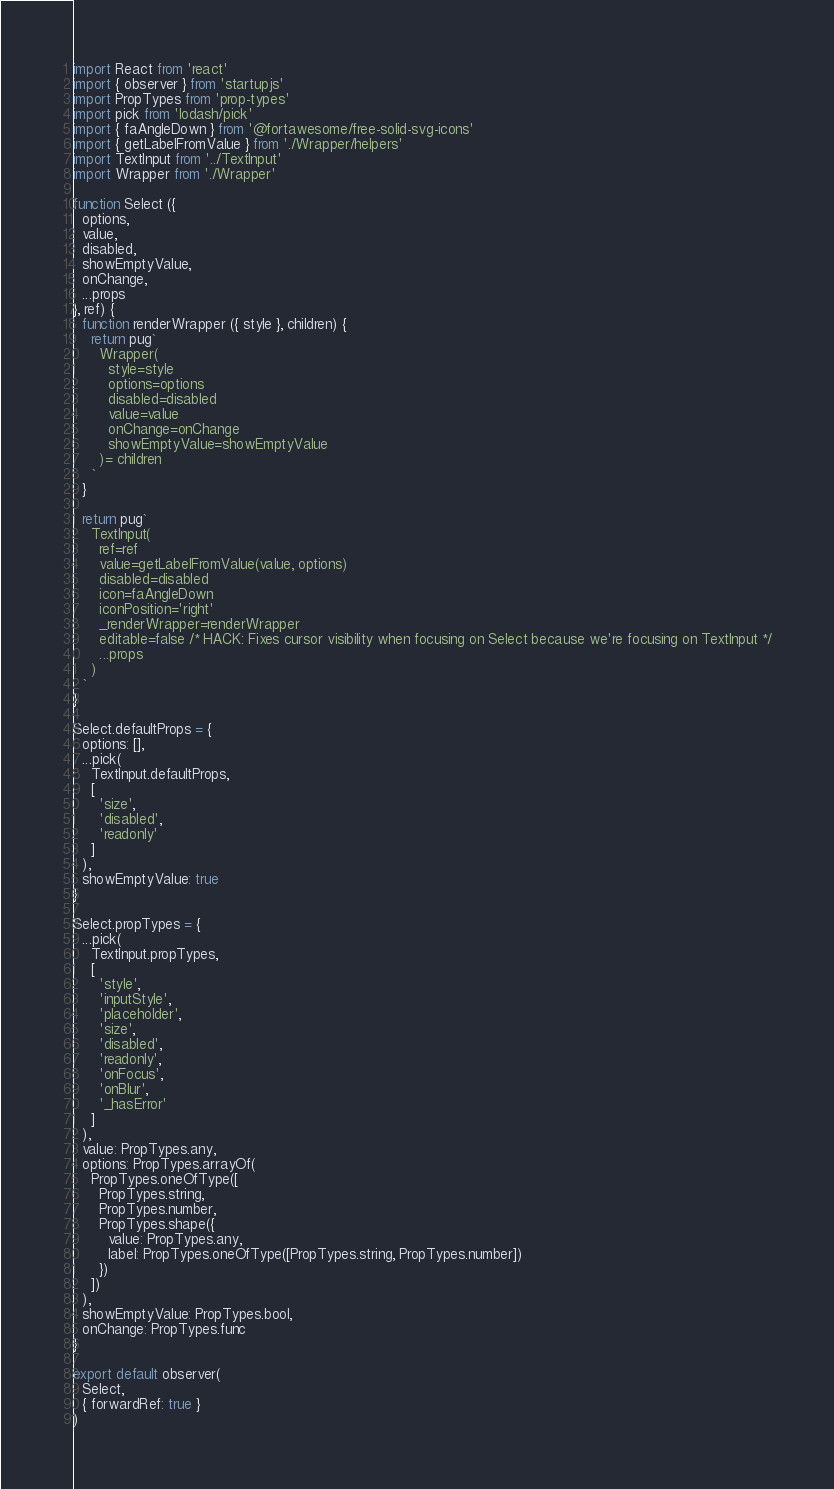<code> <loc_0><loc_0><loc_500><loc_500><_JavaScript_>import React from 'react'
import { observer } from 'startupjs'
import PropTypes from 'prop-types'
import pick from 'lodash/pick'
import { faAngleDown } from '@fortawesome/free-solid-svg-icons'
import { getLabelFromValue } from './Wrapper/helpers'
import TextInput from '../TextInput'
import Wrapper from './Wrapper'

function Select ({
  options,
  value,
  disabled,
  showEmptyValue,
  onChange,
  ...props
}, ref) {
  function renderWrapper ({ style }, children) {
    return pug`
      Wrapper(
        style=style
        options=options
        disabled=disabled
        value=value
        onChange=onChange
        showEmptyValue=showEmptyValue
      )= children
    `
  }

  return pug`
    TextInput(
      ref=ref
      value=getLabelFromValue(value, options)
      disabled=disabled
      icon=faAngleDown
      iconPosition='right'
      _renderWrapper=renderWrapper
      editable=false /* HACK: Fixes cursor visibility when focusing on Select because we're focusing on TextInput */
      ...props
    )
  `
}

Select.defaultProps = {
  options: [],
  ...pick(
    TextInput.defaultProps,
    [
      'size',
      'disabled',
      'readonly'
    ]
  ),
  showEmptyValue: true
}

Select.propTypes = {
  ...pick(
    TextInput.propTypes,
    [
      'style',
      'inputStyle',
      'placeholder',
      'size',
      'disabled',
      'readonly',
      'onFocus',
      'onBlur',
      '_hasError'
    ]
  ),
  value: PropTypes.any,
  options: PropTypes.arrayOf(
    PropTypes.oneOfType([
      PropTypes.string,
      PropTypes.number,
      PropTypes.shape({
        value: PropTypes.any,
        label: PropTypes.oneOfType([PropTypes.string, PropTypes.number])
      })
    ])
  ),
  showEmptyValue: PropTypes.bool,
  onChange: PropTypes.func
}

export default observer(
  Select,
  { forwardRef: true }
)
</code> 